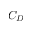Convert formula to latex. <formula><loc_0><loc_0><loc_500><loc_500>C _ { D }</formula> 